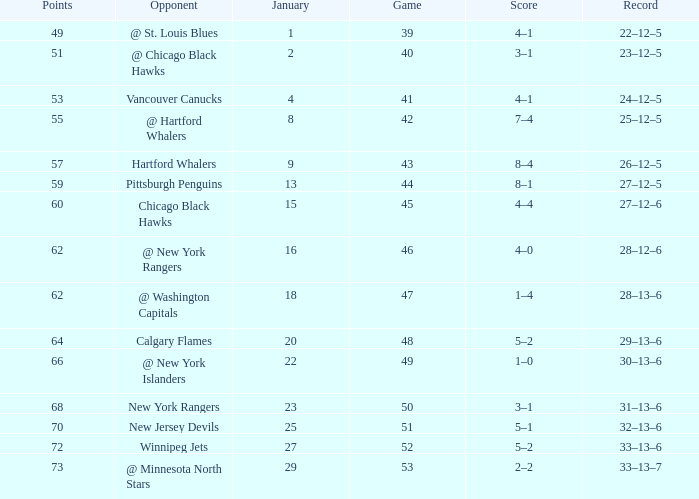How many games have a Score of 1–0, and Points smaller than 66? 0.0. Give me the full table as a dictionary. {'header': ['Points', 'Opponent', 'January', 'Game', 'Score', 'Record'], 'rows': [['49', '@ St. Louis Blues', '1', '39', '4–1', '22–12–5'], ['51', '@ Chicago Black Hawks', '2', '40', '3–1', '23–12–5'], ['53', 'Vancouver Canucks', '4', '41', '4–1', '24–12–5'], ['55', '@ Hartford Whalers', '8', '42', '7–4', '25–12–5'], ['57', 'Hartford Whalers', '9', '43', '8–4', '26–12–5'], ['59', 'Pittsburgh Penguins', '13', '44', '8–1', '27–12–5'], ['60', 'Chicago Black Hawks', '15', '45', '4–4', '27–12–6'], ['62', '@ New York Rangers', '16', '46', '4–0', '28–12–6'], ['62', '@ Washington Capitals', '18', '47', '1–4', '28–13–6'], ['64', 'Calgary Flames', '20', '48', '5–2', '29–13–6'], ['66', '@ New York Islanders', '22', '49', '1–0', '30–13–6'], ['68', 'New York Rangers', '23', '50', '3–1', '31–13–6'], ['70', 'New Jersey Devils', '25', '51', '5–1', '32–13–6'], ['72', 'Winnipeg Jets', '27', '52', '5–2', '33–13–6'], ['73', '@ Minnesota North Stars', '29', '53', '2–2', '33–13–7']]} 